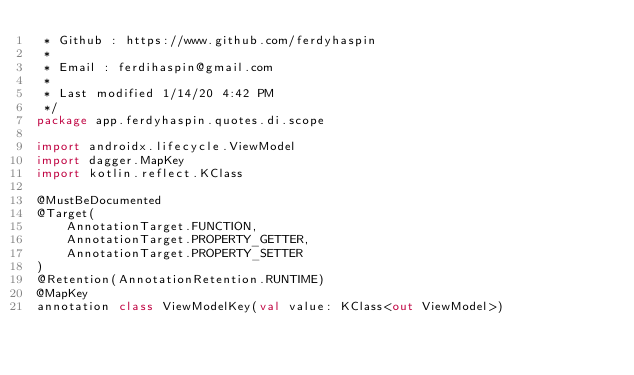<code> <loc_0><loc_0><loc_500><loc_500><_Kotlin_> * Github : https://www.github.com/ferdyhaspin
 *
 * Email : ferdihaspin@gmail.com
 *
 * Last modified 1/14/20 4:42 PM
 */
package app.ferdyhaspin.quotes.di.scope

import androidx.lifecycle.ViewModel
import dagger.MapKey
import kotlin.reflect.KClass

@MustBeDocumented
@Target(
    AnnotationTarget.FUNCTION,
    AnnotationTarget.PROPERTY_GETTER,
    AnnotationTarget.PROPERTY_SETTER
)
@Retention(AnnotationRetention.RUNTIME)
@MapKey
annotation class ViewModelKey(val value: KClass<out ViewModel>)
</code> 